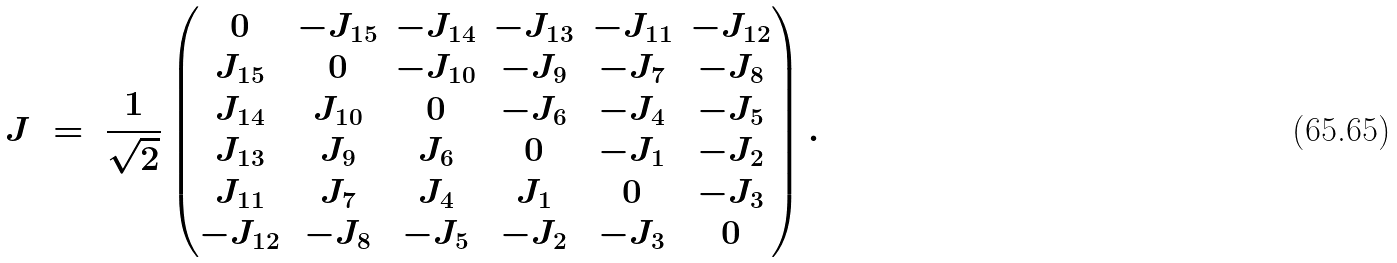Convert formula to latex. <formula><loc_0><loc_0><loc_500><loc_500>J \ = \ \frac { 1 } { \sqrt { 2 } } \begin{pmatrix} 0 & - J _ { 1 5 } & - J _ { 1 4 } & - J _ { 1 3 } & - J _ { 1 1 } & - J _ { 1 2 } \\ J _ { 1 5 } & 0 & - J _ { 1 0 } & - J _ { 9 } & - J _ { 7 } & - J _ { 8 } \\ J _ { 1 4 } & J _ { 1 0 } & 0 & - J _ { 6 } & - J _ { 4 } & - J _ { 5 } \\ J _ { 1 3 } & J _ { 9 } & J _ { 6 } & 0 & - J _ { 1 } & - J _ { 2 } \\ J _ { 1 1 } & J _ { 7 } & J _ { 4 } & J _ { 1 } & 0 & - J _ { 3 } \\ - J _ { 1 2 } & - J _ { 8 } & - J _ { 5 } & - J _ { 2 } & - J _ { 3 } & 0 \end{pmatrix} .</formula> 